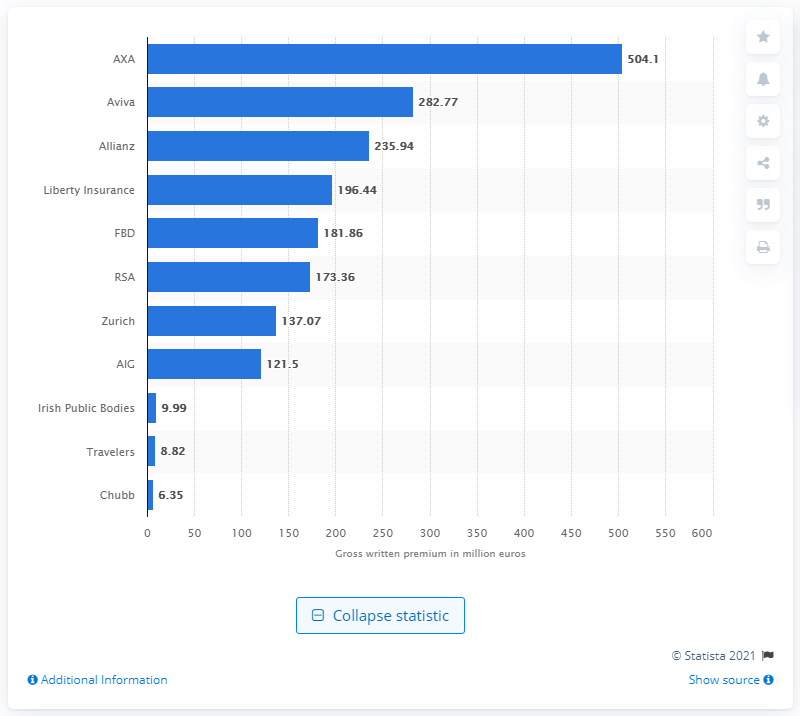Outline some significant characteristics in this image. AXA's total gross written premium for the motor insurance sector in 2018 was 504.1 million. 